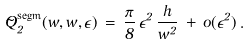Convert formula to latex. <formula><loc_0><loc_0><loc_500><loc_500>\tilde { Q } _ { 2 } ^ { \text {segm} } ( w , \bar { w } , \epsilon ) \, = \, \frac { \pi } { 8 } \, \epsilon ^ { 2 } \, \frac { h } { w ^ { 2 } } \, + \, o ( \epsilon ^ { 2 } ) \, .</formula> 